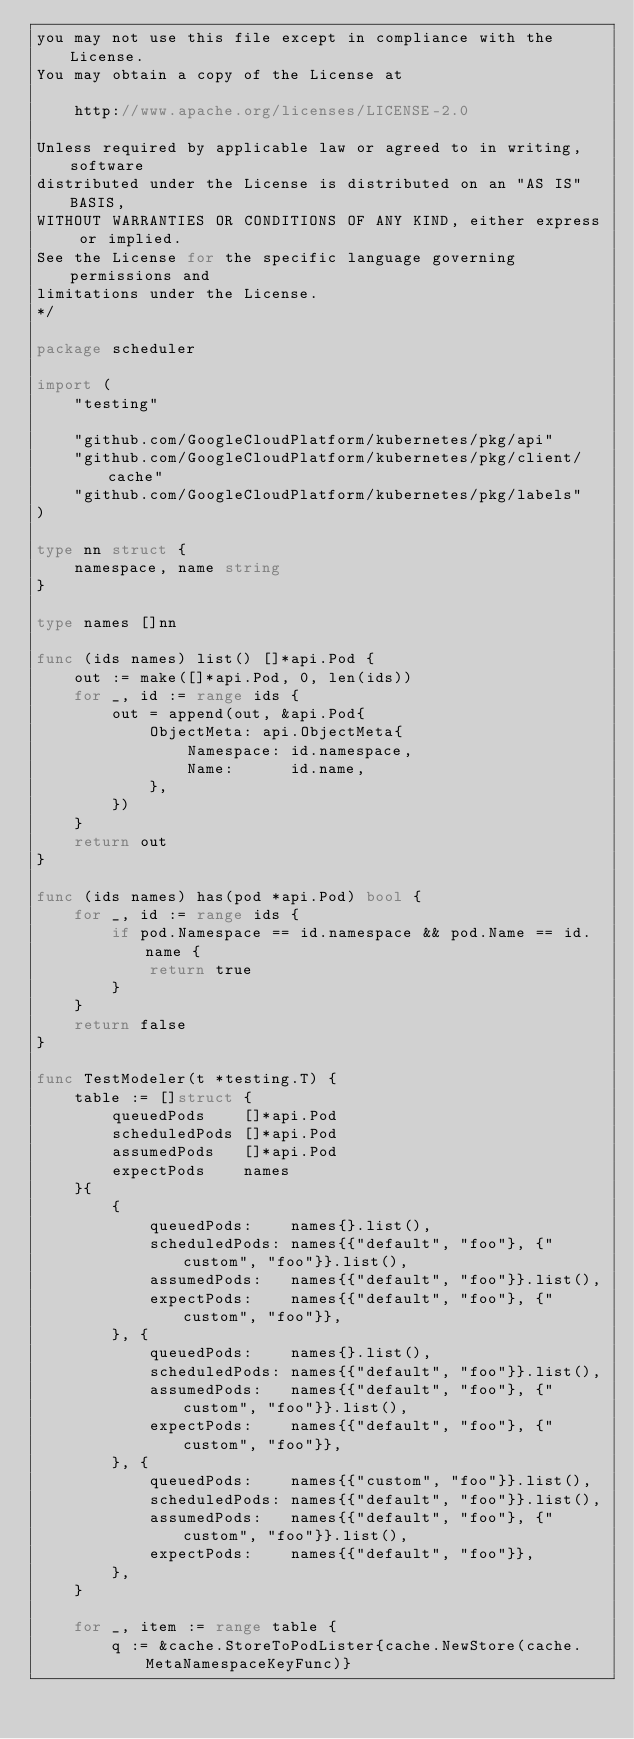Convert code to text. <code><loc_0><loc_0><loc_500><loc_500><_Go_>you may not use this file except in compliance with the License.
You may obtain a copy of the License at

    http://www.apache.org/licenses/LICENSE-2.0

Unless required by applicable law or agreed to in writing, software
distributed under the License is distributed on an "AS IS" BASIS,
WITHOUT WARRANTIES OR CONDITIONS OF ANY KIND, either express or implied.
See the License for the specific language governing permissions and
limitations under the License.
*/

package scheduler

import (
	"testing"

	"github.com/GoogleCloudPlatform/kubernetes/pkg/api"
	"github.com/GoogleCloudPlatform/kubernetes/pkg/client/cache"
	"github.com/GoogleCloudPlatform/kubernetes/pkg/labels"
)

type nn struct {
	namespace, name string
}

type names []nn

func (ids names) list() []*api.Pod {
	out := make([]*api.Pod, 0, len(ids))
	for _, id := range ids {
		out = append(out, &api.Pod{
			ObjectMeta: api.ObjectMeta{
				Namespace: id.namespace,
				Name:      id.name,
			},
		})
	}
	return out
}

func (ids names) has(pod *api.Pod) bool {
	for _, id := range ids {
		if pod.Namespace == id.namespace && pod.Name == id.name {
			return true
		}
	}
	return false
}

func TestModeler(t *testing.T) {
	table := []struct {
		queuedPods    []*api.Pod
		scheduledPods []*api.Pod
		assumedPods   []*api.Pod
		expectPods    names
	}{
		{
			queuedPods:    names{}.list(),
			scheduledPods: names{{"default", "foo"}, {"custom", "foo"}}.list(),
			assumedPods:   names{{"default", "foo"}}.list(),
			expectPods:    names{{"default", "foo"}, {"custom", "foo"}},
		}, {
			queuedPods:    names{}.list(),
			scheduledPods: names{{"default", "foo"}}.list(),
			assumedPods:   names{{"default", "foo"}, {"custom", "foo"}}.list(),
			expectPods:    names{{"default", "foo"}, {"custom", "foo"}},
		}, {
			queuedPods:    names{{"custom", "foo"}}.list(),
			scheduledPods: names{{"default", "foo"}}.list(),
			assumedPods:   names{{"default", "foo"}, {"custom", "foo"}}.list(),
			expectPods:    names{{"default", "foo"}},
		},
	}

	for _, item := range table {
		q := &cache.StoreToPodLister{cache.NewStore(cache.MetaNamespaceKeyFunc)}</code> 